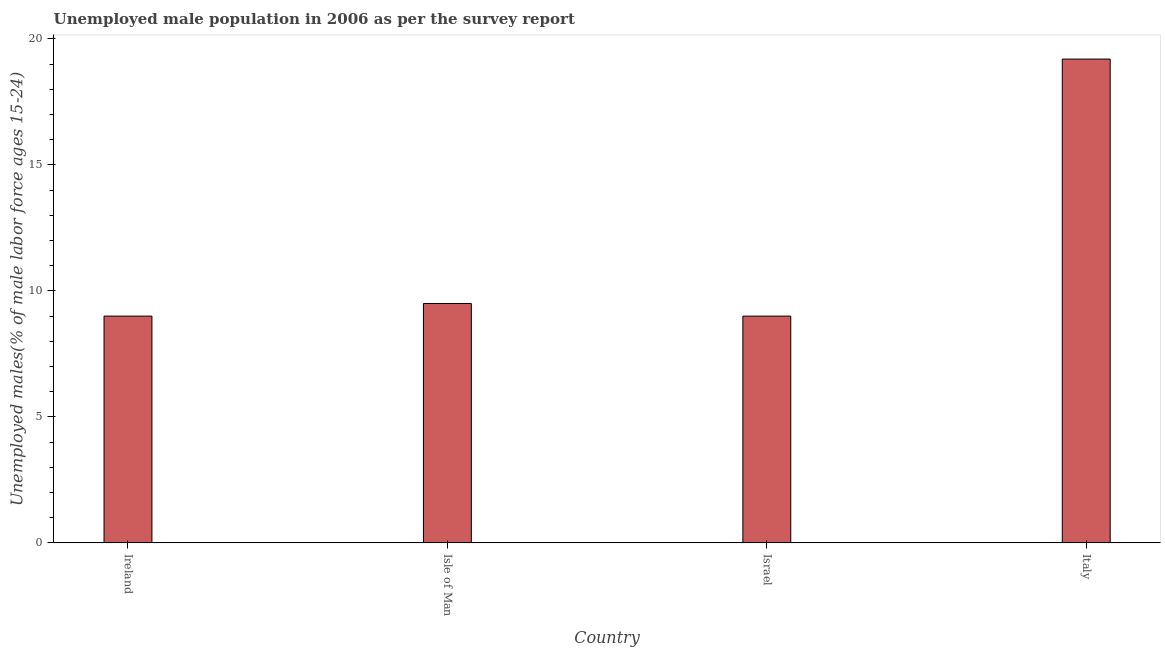Does the graph contain grids?
Your response must be concise. No. What is the title of the graph?
Your answer should be compact. Unemployed male population in 2006 as per the survey report. What is the label or title of the Y-axis?
Provide a short and direct response. Unemployed males(% of male labor force ages 15-24). What is the unemployed male youth in Isle of Man?
Provide a short and direct response. 9.5. Across all countries, what is the maximum unemployed male youth?
Offer a very short reply. 19.2. Across all countries, what is the minimum unemployed male youth?
Your answer should be compact. 9. In which country was the unemployed male youth maximum?
Offer a terse response. Italy. In which country was the unemployed male youth minimum?
Your answer should be compact. Ireland. What is the sum of the unemployed male youth?
Your response must be concise. 46.7. What is the difference between the unemployed male youth in Ireland and Isle of Man?
Ensure brevity in your answer.  -0.5. What is the average unemployed male youth per country?
Provide a short and direct response. 11.68. What is the median unemployed male youth?
Your answer should be very brief. 9.25. What is the ratio of the unemployed male youth in Ireland to that in Italy?
Give a very brief answer. 0.47. Is the unemployed male youth in Isle of Man less than that in Israel?
Provide a short and direct response. No. Is the difference between the unemployed male youth in Isle of Man and Israel greater than the difference between any two countries?
Offer a very short reply. No. What is the difference between the highest and the second highest unemployed male youth?
Keep it short and to the point. 9.7. Is the sum of the unemployed male youth in Ireland and Italy greater than the maximum unemployed male youth across all countries?
Offer a terse response. Yes. Are all the bars in the graph horizontal?
Provide a succinct answer. No. What is the difference between two consecutive major ticks on the Y-axis?
Offer a terse response. 5. What is the Unemployed males(% of male labor force ages 15-24) in Ireland?
Give a very brief answer. 9. What is the Unemployed males(% of male labor force ages 15-24) of Italy?
Keep it short and to the point. 19.2. What is the difference between the Unemployed males(% of male labor force ages 15-24) in Ireland and Isle of Man?
Your answer should be compact. -0.5. What is the ratio of the Unemployed males(% of male labor force ages 15-24) in Ireland to that in Isle of Man?
Your answer should be very brief. 0.95. What is the ratio of the Unemployed males(% of male labor force ages 15-24) in Ireland to that in Israel?
Your response must be concise. 1. What is the ratio of the Unemployed males(% of male labor force ages 15-24) in Ireland to that in Italy?
Offer a very short reply. 0.47. What is the ratio of the Unemployed males(% of male labor force ages 15-24) in Isle of Man to that in Israel?
Your response must be concise. 1.06. What is the ratio of the Unemployed males(% of male labor force ages 15-24) in Isle of Man to that in Italy?
Your answer should be compact. 0.49. What is the ratio of the Unemployed males(% of male labor force ages 15-24) in Israel to that in Italy?
Offer a very short reply. 0.47. 